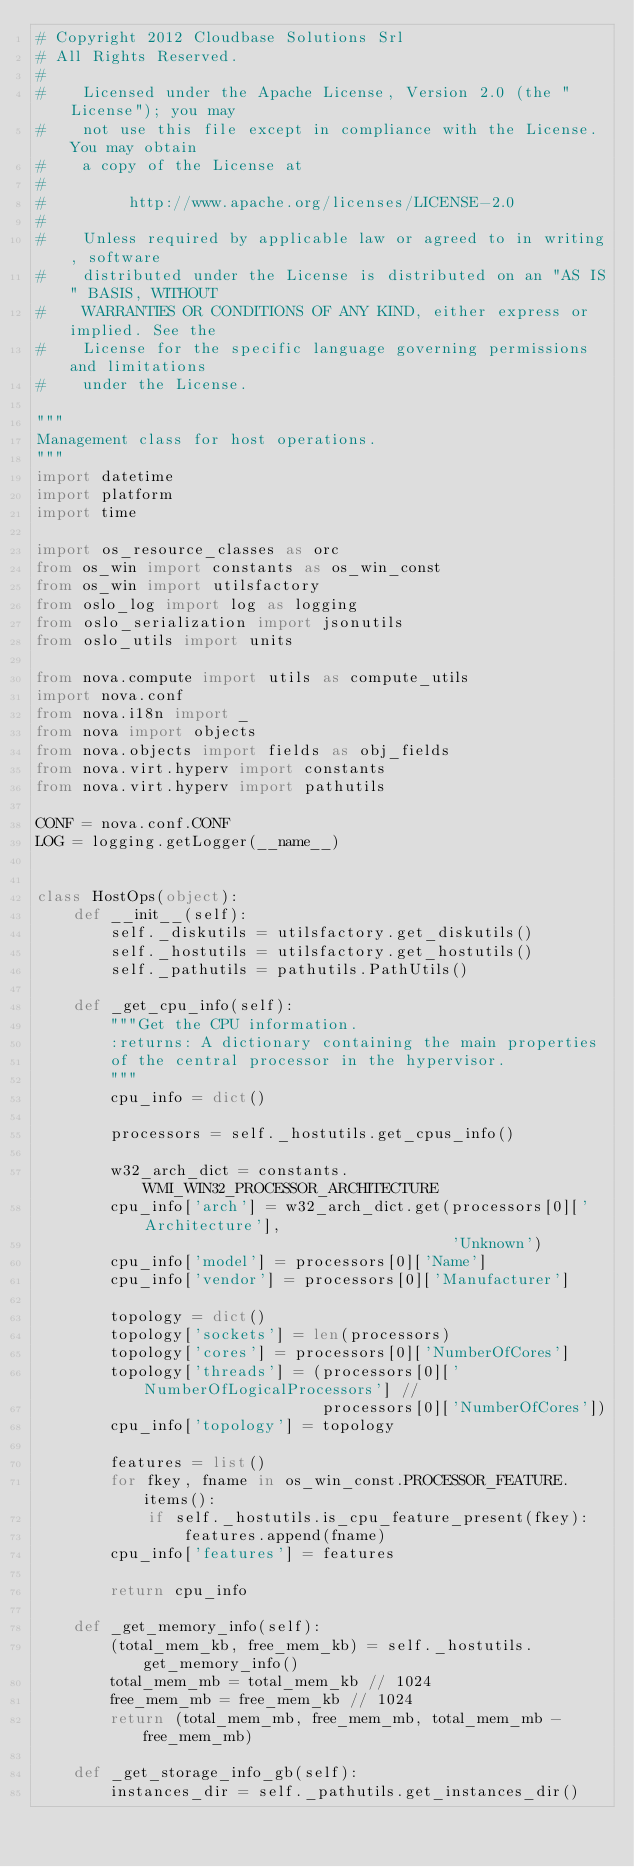Convert code to text. <code><loc_0><loc_0><loc_500><loc_500><_Python_># Copyright 2012 Cloudbase Solutions Srl
# All Rights Reserved.
#
#    Licensed under the Apache License, Version 2.0 (the "License"); you may
#    not use this file except in compliance with the License. You may obtain
#    a copy of the License at
#
#         http://www.apache.org/licenses/LICENSE-2.0
#
#    Unless required by applicable law or agreed to in writing, software
#    distributed under the License is distributed on an "AS IS" BASIS, WITHOUT
#    WARRANTIES OR CONDITIONS OF ANY KIND, either express or implied. See the
#    License for the specific language governing permissions and limitations
#    under the License.

"""
Management class for host operations.
"""
import datetime
import platform
import time

import os_resource_classes as orc
from os_win import constants as os_win_const
from os_win import utilsfactory
from oslo_log import log as logging
from oslo_serialization import jsonutils
from oslo_utils import units

from nova.compute import utils as compute_utils
import nova.conf
from nova.i18n import _
from nova import objects
from nova.objects import fields as obj_fields
from nova.virt.hyperv import constants
from nova.virt.hyperv import pathutils

CONF = nova.conf.CONF
LOG = logging.getLogger(__name__)


class HostOps(object):
    def __init__(self):
        self._diskutils = utilsfactory.get_diskutils()
        self._hostutils = utilsfactory.get_hostutils()
        self._pathutils = pathutils.PathUtils()

    def _get_cpu_info(self):
        """Get the CPU information.
        :returns: A dictionary containing the main properties
        of the central processor in the hypervisor.
        """
        cpu_info = dict()

        processors = self._hostutils.get_cpus_info()

        w32_arch_dict = constants.WMI_WIN32_PROCESSOR_ARCHITECTURE
        cpu_info['arch'] = w32_arch_dict.get(processors[0]['Architecture'],
                                             'Unknown')
        cpu_info['model'] = processors[0]['Name']
        cpu_info['vendor'] = processors[0]['Manufacturer']

        topology = dict()
        topology['sockets'] = len(processors)
        topology['cores'] = processors[0]['NumberOfCores']
        topology['threads'] = (processors[0]['NumberOfLogicalProcessors'] //
                               processors[0]['NumberOfCores'])
        cpu_info['topology'] = topology

        features = list()
        for fkey, fname in os_win_const.PROCESSOR_FEATURE.items():
            if self._hostutils.is_cpu_feature_present(fkey):
                features.append(fname)
        cpu_info['features'] = features

        return cpu_info

    def _get_memory_info(self):
        (total_mem_kb, free_mem_kb) = self._hostutils.get_memory_info()
        total_mem_mb = total_mem_kb // 1024
        free_mem_mb = free_mem_kb // 1024
        return (total_mem_mb, free_mem_mb, total_mem_mb - free_mem_mb)

    def _get_storage_info_gb(self):
        instances_dir = self._pathutils.get_instances_dir()</code> 